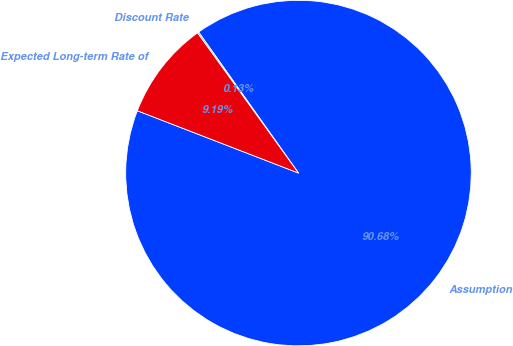Convert chart. <chart><loc_0><loc_0><loc_500><loc_500><pie_chart><fcel>Assumption<fcel>Discount Rate<fcel>Expected Long-term Rate of<nl><fcel>90.68%<fcel>0.13%<fcel>9.19%<nl></chart> 